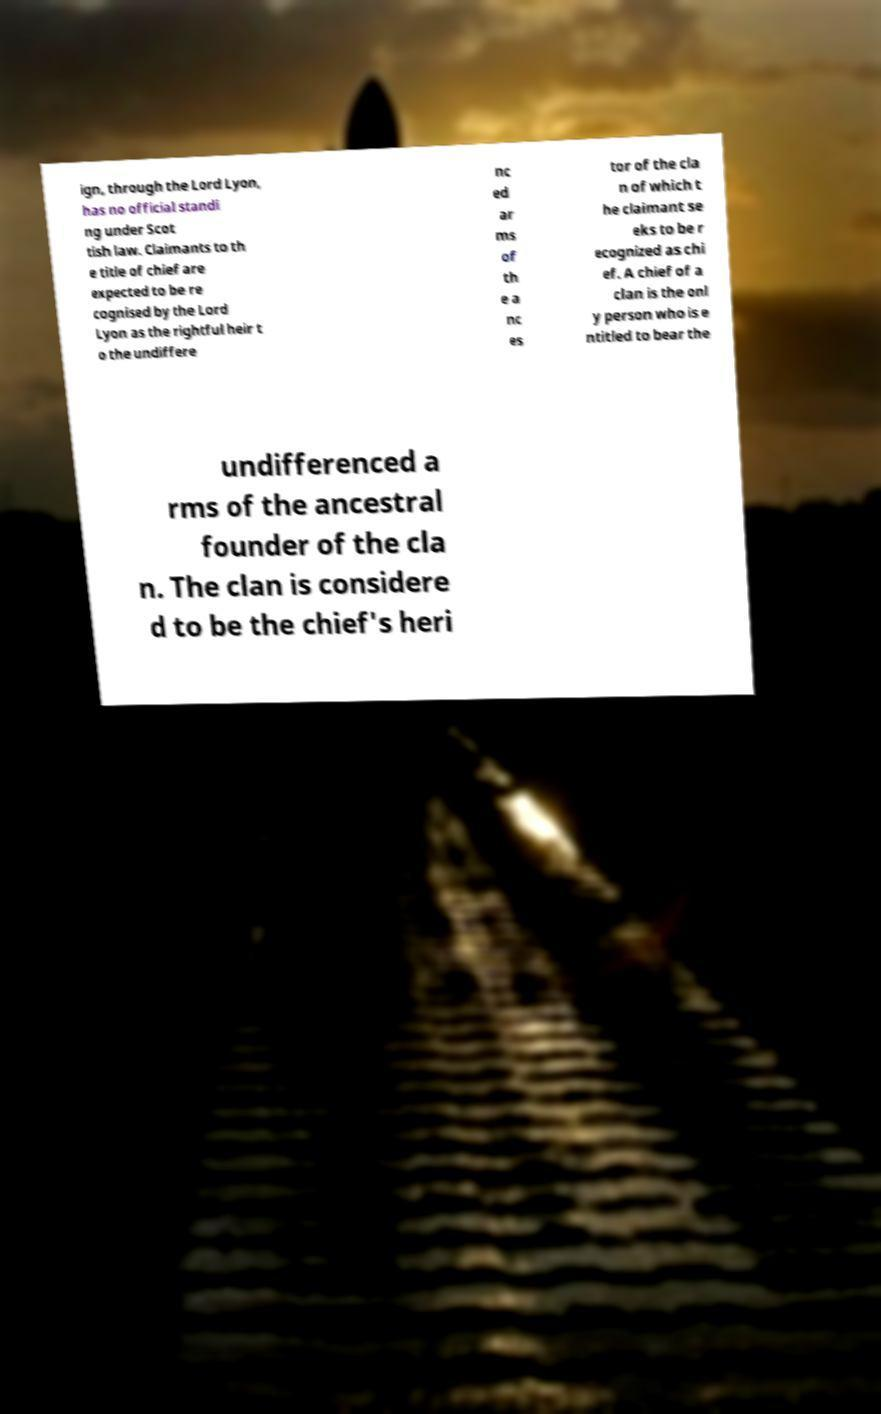Can you accurately transcribe the text from the provided image for me? ign, through the Lord Lyon, has no official standi ng under Scot tish law. Claimants to th e title of chief are expected to be re cognised by the Lord Lyon as the rightful heir t o the undiffere nc ed ar ms of th e a nc es tor of the cla n of which t he claimant se eks to be r ecognized as chi ef. A chief of a clan is the onl y person who is e ntitled to bear the undifferenced a rms of the ancestral founder of the cla n. The clan is considere d to be the chief's heri 